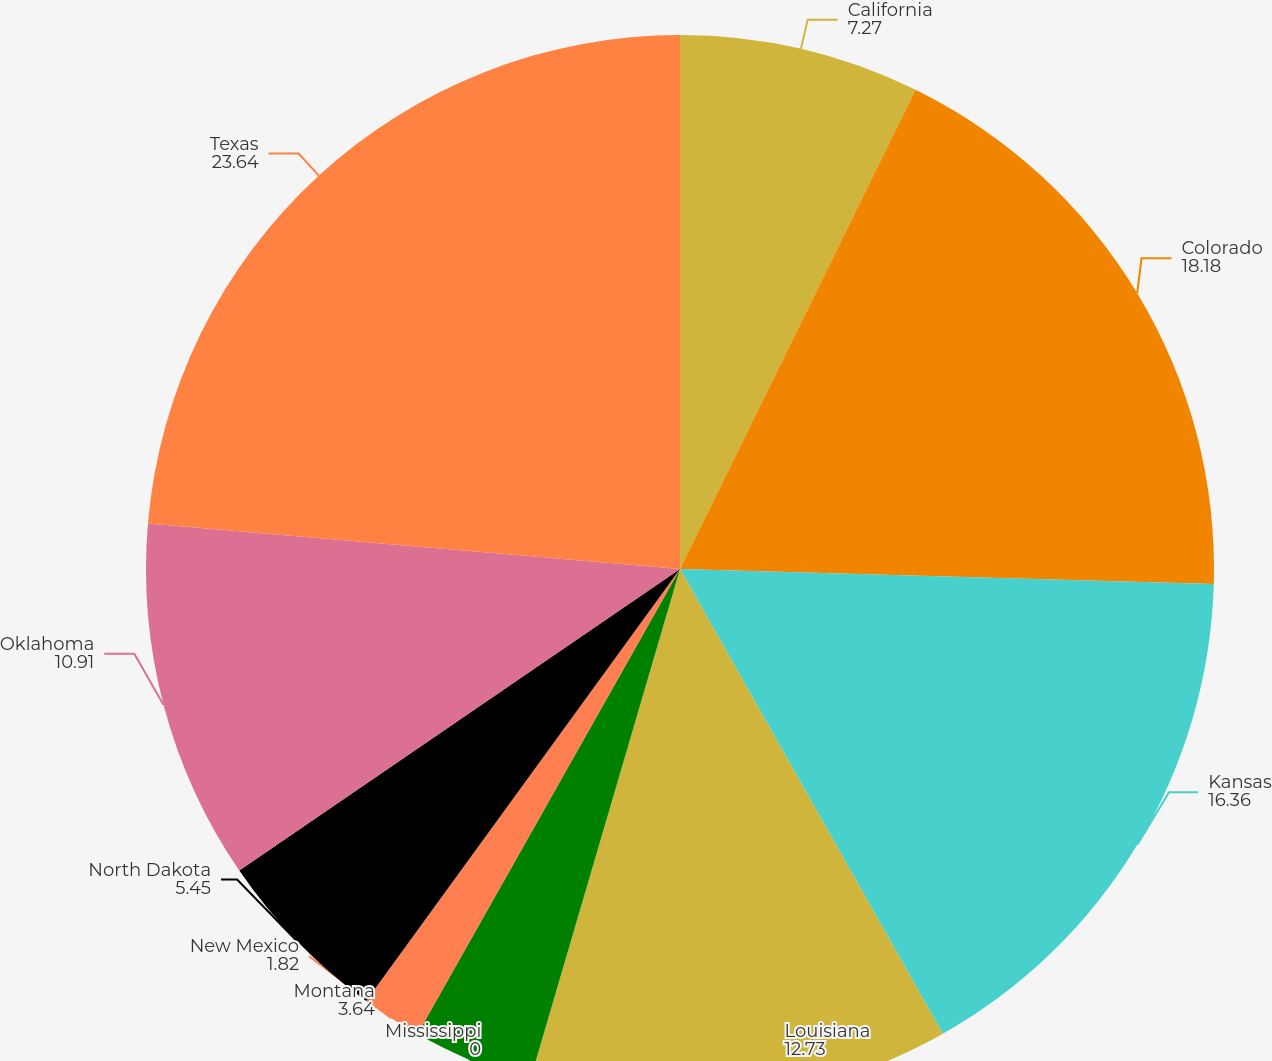<chart> <loc_0><loc_0><loc_500><loc_500><pie_chart><fcel>California<fcel>Colorado<fcel>Kansas<fcel>Louisiana<fcel>Mississippi<fcel>Montana<fcel>New Mexico<fcel>North Dakota<fcel>Oklahoma<fcel>Texas<nl><fcel>7.27%<fcel>18.18%<fcel>16.36%<fcel>12.73%<fcel>0.0%<fcel>3.64%<fcel>1.82%<fcel>5.45%<fcel>10.91%<fcel>23.64%<nl></chart> 